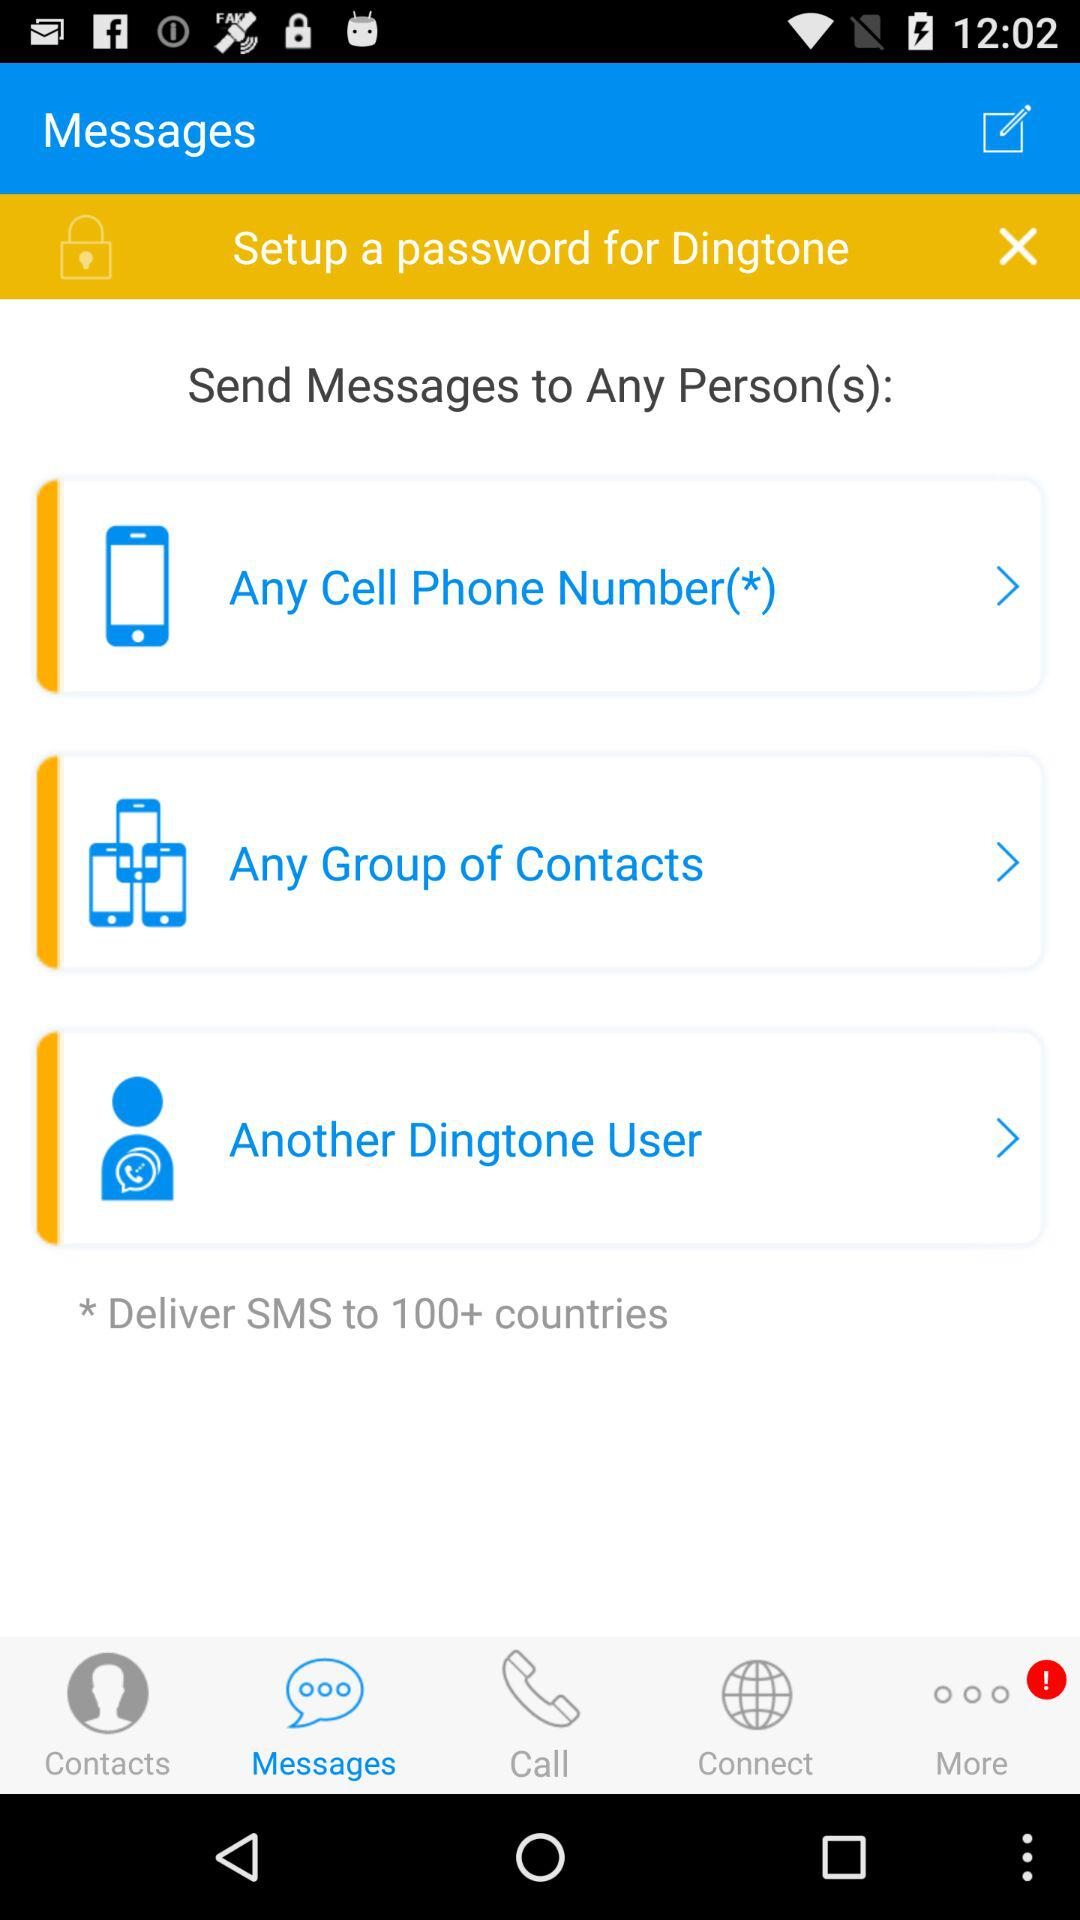Which tab is selected? The selected tab is "Messages". 